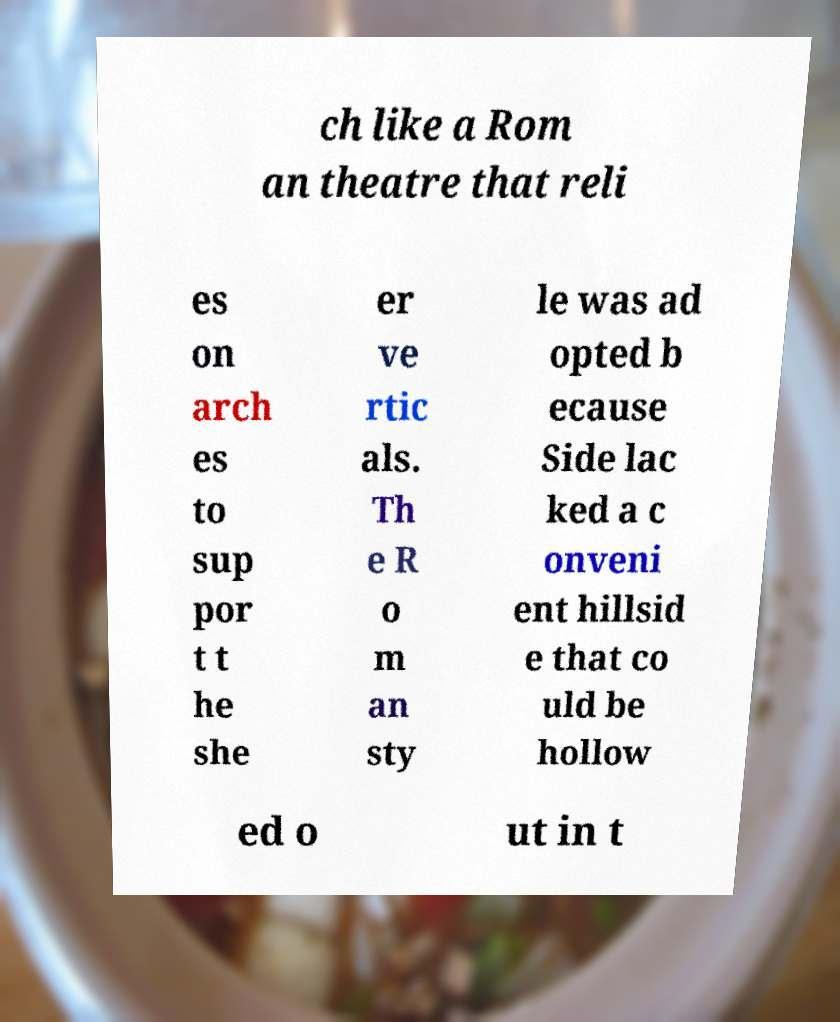I need the written content from this picture converted into text. Can you do that? ch like a Rom an theatre that reli es on arch es to sup por t t he she er ve rtic als. Th e R o m an sty le was ad opted b ecause Side lac ked a c onveni ent hillsid e that co uld be hollow ed o ut in t 